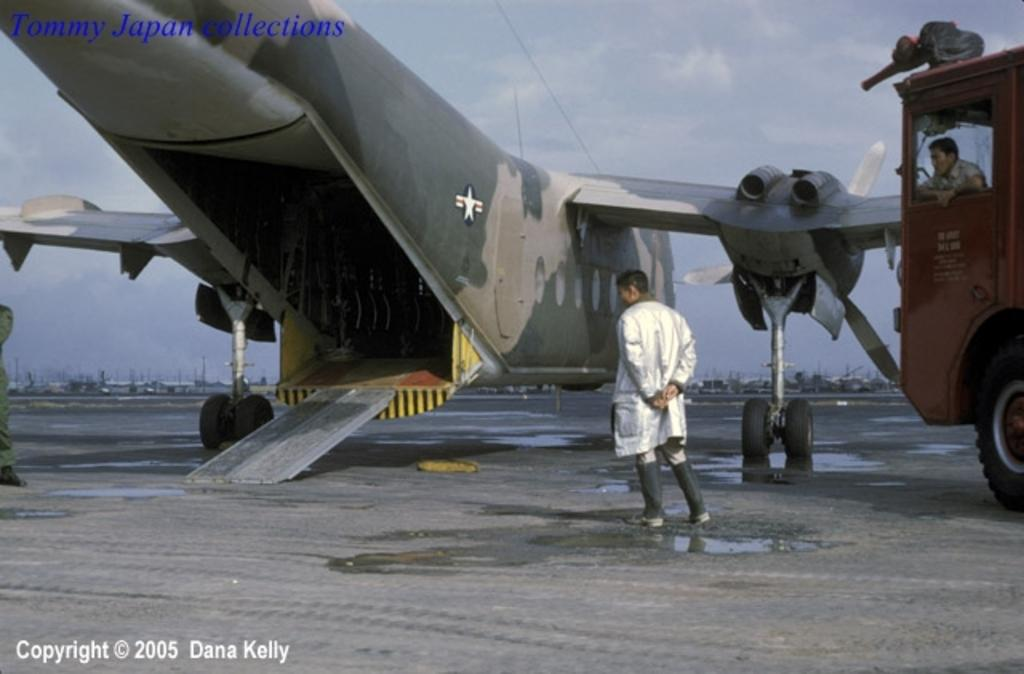What is the main subject of the picture? The main subject of the picture is an aircraft. Can you describe the man in the picture? There is a man standing in the picture, and he is wearing a coat. What else can be seen in the picture besides the aircraft and the man? There is a vehicle in the picture, and a man is seated in it. Additionally, there are boats in the picture. How would you describe the sky in the picture? The sky is blue and cloudy in the picture. How many buttons are visible on the man's coat in the image? There is no information about the number of buttons on the man's coat in the image. Is there a chain connecting the aircraft to the vehicle in the image? There is no chain connecting the aircraft to the vehicle in the image. 